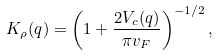<formula> <loc_0><loc_0><loc_500><loc_500>K _ { \rho } ( q ) = \left ( 1 + \frac { 2 V _ { c } ( q ) } { \pi v _ { F } } \right ) ^ { - 1 / 2 } ,</formula> 